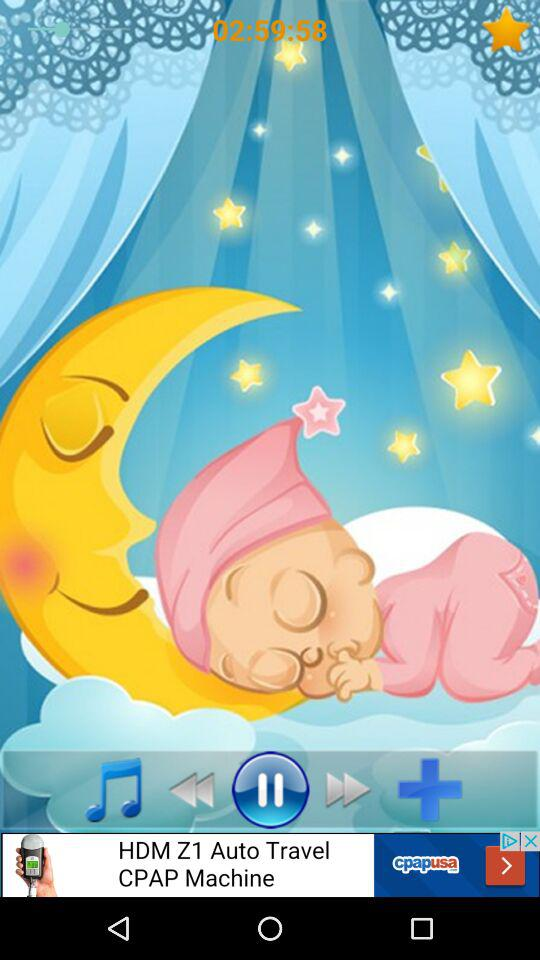What is the given time? The given time is 02:59:58. 